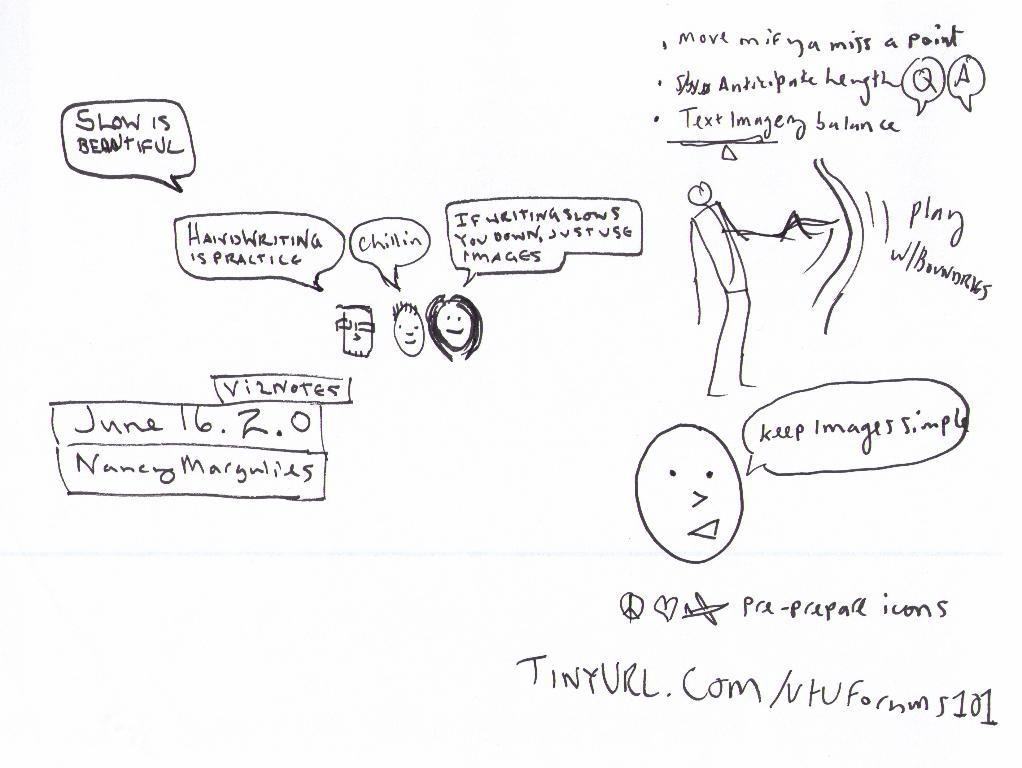What is present on the paper in the image? There is handwritten text and sketches on the paper. Can you describe the content of the handwritten text? Unfortunately, the specific content of the handwritten text cannot be determined from the image alone. What type of sketches can be seen on the paper? The nature of the sketches cannot be determined from the image alone. What is the hand doing in the image? There is no hand visible in the image; it only shows a paper with handwritten text and sketches. Does the owner of the paper exist in the image? The image does not show the owner of the paper, only the paper itself. 